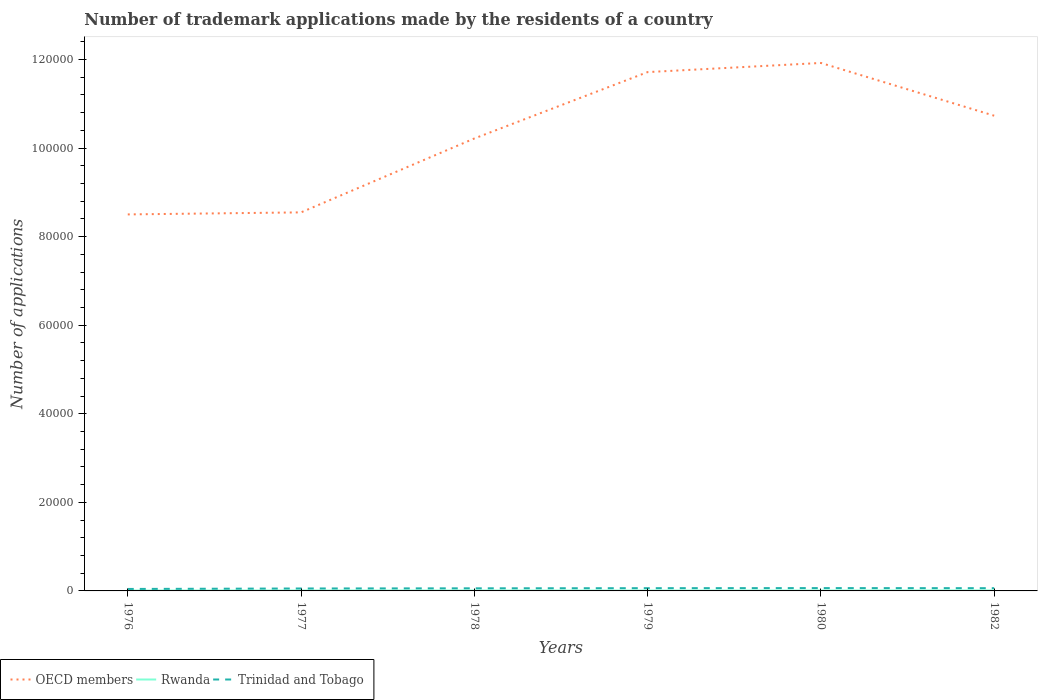How many different coloured lines are there?
Provide a short and direct response. 3. Across all years, what is the maximum number of trademark applications made by the residents in OECD members?
Provide a succinct answer. 8.50e+04. In which year was the number of trademark applications made by the residents in Rwanda maximum?
Offer a terse response. 1979. What is the difference between the highest and the second highest number of trademark applications made by the residents in OECD members?
Your answer should be compact. 3.42e+04. Is the number of trademark applications made by the residents in Rwanda strictly greater than the number of trademark applications made by the residents in OECD members over the years?
Keep it short and to the point. Yes. How many years are there in the graph?
Keep it short and to the point. 6. Are the values on the major ticks of Y-axis written in scientific E-notation?
Offer a terse response. No. Does the graph contain grids?
Ensure brevity in your answer.  No. How are the legend labels stacked?
Make the answer very short. Horizontal. What is the title of the graph?
Ensure brevity in your answer.  Number of trademark applications made by the residents of a country. Does "Azerbaijan" appear as one of the legend labels in the graph?
Your response must be concise. No. What is the label or title of the X-axis?
Make the answer very short. Years. What is the label or title of the Y-axis?
Offer a very short reply. Number of applications. What is the Number of applications in OECD members in 1976?
Keep it short and to the point. 8.50e+04. What is the Number of applications of Trinidad and Tobago in 1976?
Offer a very short reply. 443. What is the Number of applications of OECD members in 1977?
Keep it short and to the point. 8.55e+04. What is the Number of applications of Rwanda in 1977?
Your answer should be very brief. 90. What is the Number of applications in Trinidad and Tobago in 1977?
Offer a very short reply. 550. What is the Number of applications of OECD members in 1978?
Offer a terse response. 1.02e+05. What is the Number of applications of Trinidad and Tobago in 1978?
Offer a very short reply. 589. What is the Number of applications of OECD members in 1979?
Your response must be concise. 1.17e+05. What is the Number of applications of Trinidad and Tobago in 1979?
Keep it short and to the point. 621. What is the Number of applications of OECD members in 1980?
Give a very brief answer. 1.19e+05. What is the Number of applications in Trinidad and Tobago in 1980?
Your answer should be compact. 640. What is the Number of applications in OECD members in 1982?
Offer a very short reply. 1.07e+05. What is the Number of applications of Rwanda in 1982?
Offer a terse response. 106. What is the Number of applications in Trinidad and Tobago in 1982?
Keep it short and to the point. 621. Across all years, what is the maximum Number of applications of OECD members?
Provide a succinct answer. 1.19e+05. Across all years, what is the maximum Number of applications in Rwanda?
Make the answer very short. 106. Across all years, what is the maximum Number of applications of Trinidad and Tobago?
Your answer should be compact. 640. Across all years, what is the minimum Number of applications in OECD members?
Offer a terse response. 8.50e+04. Across all years, what is the minimum Number of applications of Trinidad and Tobago?
Keep it short and to the point. 443. What is the total Number of applications of OECD members in the graph?
Ensure brevity in your answer.  6.16e+05. What is the total Number of applications in Rwanda in the graph?
Your answer should be compact. 537. What is the total Number of applications of Trinidad and Tobago in the graph?
Offer a very short reply. 3464. What is the difference between the Number of applications in OECD members in 1976 and that in 1977?
Your answer should be compact. -459. What is the difference between the Number of applications in Trinidad and Tobago in 1976 and that in 1977?
Offer a terse response. -107. What is the difference between the Number of applications of OECD members in 1976 and that in 1978?
Offer a terse response. -1.71e+04. What is the difference between the Number of applications in Trinidad and Tobago in 1976 and that in 1978?
Your answer should be compact. -146. What is the difference between the Number of applications of OECD members in 1976 and that in 1979?
Offer a terse response. -3.21e+04. What is the difference between the Number of applications in Trinidad and Tobago in 1976 and that in 1979?
Ensure brevity in your answer.  -178. What is the difference between the Number of applications in OECD members in 1976 and that in 1980?
Your answer should be very brief. -3.42e+04. What is the difference between the Number of applications of Trinidad and Tobago in 1976 and that in 1980?
Give a very brief answer. -197. What is the difference between the Number of applications in OECD members in 1976 and that in 1982?
Make the answer very short. -2.23e+04. What is the difference between the Number of applications of Rwanda in 1976 and that in 1982?
Give a very brief answer. -23. What is the difference between the Number of applications of Trinidad and Tobago in 1976 and that in 1982?
Give a very brief answer. -178. What is the difference between the Number of applications of OECD members in 1977 and that in 1978?
Your response must be concise. -1.67e+04. What is the difference between the Number of applications of Trinidad and Tobago in 1977 and that in 1978?
Offer a very short reply. -39. What is the difference between the Number of applications in OECD members in 1977 and that in 1979?
Your answer should be very brief. -3.17e+04. What is the difference between the Number of applications in Trinidad and Tobago in 1977 and that in 1979?
Make the answer very short. -71. What is the difference between the Number of applications in OECD members in 1977 and that in 1980?
Provide a succinct answer. -3.37e+04. What is the difference between the Number of applications in Trinidad and Tobago in 1977 and that in 1980?
Make the answer very short. -90. What is the difference between the Number of applications in OECD members in 1977 and that in 1982?
Give a very brief answer. -2.18e+04. What is the difference between the Number of applications of Trinidad and Tobago in 1977 and that in 1982?
Keep it short and to the point. -71. What is the difference between the Number of applications of OECD members in 1978 and that in 1979?
Provide a short and direct response. -1.50e+04. What is the difference between the Number of applications in Trinidad and Tobago in 1978 and that in 1979?
Ensure brevity in your answer.  -32. What is the difference between the Number of applications in OECD members in 1978 and that in 1980?
Your answer should be compact. -1.71e+04. What is the difference between the Number of applications of Rwanda in 1978 and that in 1980?
Offer a very short reply. 3. What is the difference between the Number of applications in Trinidad and Tobago in 1978 and that in 1980?
Ensure brevity in your answer.  -51. What is the difference between the Number of applications in OECD members in 1978 and that in 1982?
Provide a succinct answer. -5143. What is the difference between the Number of applications of Rwanda in 1978 and that in 1982?
Offer a terse response. -16. What is the difference between the Number of applications of Trinidad and Tobago in 1978 and that in 1982?
Your answer should be very brief. -32. What is the difference between the Number of applications in OECD members in 1979 and that in 1980?
Provide a succinct answer. -2065. What is the difference between the Number of applications in OECD members in 1979 and that in 1982?
Ensure brevity in your answer.  9848. What is the difference between the Number of applications in Rwanda in 1979 and that in 1982?
Your response must be concise. -25. What is the difference between the Number of applications in Trinidad and Tobago in 1979 and that in 1982?
Offer a very short reply. 0. What is the difference between the Number of applications of OECD members in 1980 and that in 1982?
Your answer should be compact. 1.19e+04. What is the difference between the Number of applications in Rwanda in 1980 and that in 1982?
Your answer should be very brief. -19. What is the difference between the Number of applications in OECD members in 1976 and the Number of applications in Rwanda in 1977?
Keep it short and to the point. 8.49e+04. What is the difference between the Number of applications of OECD members in 1976 and the Number of applications of Trinidad and Tobago in 1977?
Make the answer very short. 8.45e+04. What is the difference between the Number of applications of Rwanda in 1976 and the Number of applications of Trinidad and Tobago in 1977?
Make the answer very short. -467. What is the difference between the Number of applications of OECD members in 1976 and the Number of applications of Rwanda in 1978?
Keep it short and to the point. 8.49e+04. What is the difference between the Number of applications in OECD members in 1976 and the Number of applications in Trinidad and Tobago in 1978?
Your answer should be compact. 8.44e+04. What is the difference between the Number of applications in Rwanda in 1976 and the Number of applications in Trinidad and Tobago in 1978?
Offer a very short reply. -506. What is the difference between the Number of applications of OECD members in 1976 and the Number of applications of Rwanda in 1979?
Offer a very short reply. 8.50e+04. What is the difference between the Number of applications in OECD members in 1976 and the Number of applications in Trinidad and Tobago in 1979?
Give a very brief answer. 8.44e+04. What is the difference between the Number of applications in Rwanda in 1976 and the Number of applications in Trinidad and Tobago in 1979?
Make the answer very short. -538. What is the difference between the Number of applications in OECD members in 1976 and the Number of applications in Rwanda in 1980?
Make the answer very short. 8.49e+04. What is the difference between the Number of applications of OECD members in 1976 and the Number of applications of Trinidad and Tobago in 1980?
Offer a very short reply. 8.44e+04. What is the difference between the Number of applications in Rwanda in 1976 and the Number of applications in Trinidad and Tobago in 1980?
Provide a succinct answer. -557. What is the difference between the Number of applications in OECD members in 1976 and the Number of applications in Rwanda in 1982?
Your answer should be very brief. 8.49e+04. What is the difference between the Number of applications in OECD members in 1976 and the Number of applications in Trinidad and Tobago in 1982?
Ensure brevity in your answer.  8.44e+04. What is the difference between the Number of applications in Rwanda in 1976 and the Number of applications in Trinidad and Tobago in 1982?
Your answer should be compact. -538. What is the difference between the Number of applications of OECD members in 1977 and the Number of applications of Rwanda in 1978?
Your answer should be very brief. 8.54e+04. What is the difference between the Number of applications in OECD members in 1977 and the Number of applications in Trinidad and Tobago in 1978?
Make the answer very short. 8.49e+04. What is the difference between the Number of applications of Rwanda in 1977 and the Number of applications of Trinidad and Tobago in 1978?
Make the answer very short. -499. What is the difference between the Number of applications of OECD members in 1977 and the Number of applications of Rwanda in 1979?
Offer a very short reply. 8.54e+04. What is the difference between the Number of applications in OECD members in 1977 and the Number of applications in Trinidad and Tobago in 1979?
Provide a short and direct response. 8.49e+04. What is the difference between the Number of applications in Rwanda in 1977 and the Number of applications in Trinidad and Tobago in 1979?
Offer a very short reply. -531. What is the difference between the Number of applications of OECD members in 1977 and the Number of applications of Rwanda in 1980?
Provide a short and direct response. 8.54e+04. What is the difference between the Number of applications in OECD members in 1977 and the Number of applications in Trinidad and Tobago in 1980?
Your response must be concise. 8.48e+04. What is the difference between the Number of applications in Rwanda in 1977 and the Number of applications in Trinidad and Tobago in 1980?
Give a very brief answer. -550. What is the difference between the Number of applications of OECD members in 1977 and the Number of applications of Rwanda in 1982?
Provide a succinct answer. 8.54e+04. What is the difference between the Number of applications of OECD members in 1977 and the Number of applications of Trinidad and Tobago in 1982?
Keep it short and to the point. 8.49e+04. What is the difference between the Number of applications in Rwanda in 1977 and the Number of applications in Trinidad and Tobago in 1982?
Ensure brevity in your answer.  -531. What is the difference between the Number of applications of OECD members in 1978 and the Number of applications of Rwanda in 1979?
Your response must be concise. 1.02e+05. What is the difference between the Number of applications of OECD members in 1978 and the Number of applications of Trinidad and Tobago in 1979?
Give a very brief answer. 1.02e+05. What is the difference between the Number of applications of Rwanda in 1978 and the Number of applications of Trinidad and Tobago in 1979?
Your answer should be very brief. -531. What is the difference between the Number of applications of OECD members in 1978 and the Number of applications of Rwanda in 1980?
Provide a short and direct response. 1.02e+05. What is the difference between the Number of applications in OECD members in 1978 and the Number of applications in Trinidad and Tobago in 1980?
Offer a very short reply. 1.02e+05. What is the difference between the Number of applications of Rwanda in 1978 and the Number of applications of Trinidad and Tobago in 1980?
Your answer should be very brief. -550. What is the difference between the Number of applications of OECD members in 1978 and the Number of applications of Rwanda in 1982?
Make the answer very short. 1.02e+05. What is the difference between the Number of applications in OECD members in 1978 and the Number of applications in Trinidad and Tobago in 1982?
Make the answer very short. 1.02e+05. What is the difference between the Number of applications in Rwanda in 1978 and the Number of applications in Trinidad and Tobago in 1982?
Your response must be concise. -531. What is the difference between the Number of applications in OECD members in 1979 and the Number of applications in Rwanda in 1980?
Give a very brief answer. 1.17e+05. What is the difference between the Number of applications in OECD members in 1979 and the Number of applications in Trinidad and Tobago in 1980?
Keep it short and to the point. 1.17e+05. What is the difference between the Number of applications of Rwanda in 1979 and the Number of applications of Trinidad and Tobago in 1980?
Ensure brevity in your answer.  -559. What is the difference between the Number of applications in OECD members in 1979 and the Number of applications in Rwanda in 1982?
Provide a succinct answer. 1.17e+05. What is the difference between the Number of applications of OECD members in 1979 and the Number of applications of Trinidad and Tobago in 1982?
Make the answer very short. 1.17e+05. What is the difference between the Number of applications in Rwanda in 1979 and the Number of applications in Trinidad and Tobago in 1982?
Make the answer very short. -540. What is the difference between the Number of applications in OECD members in 1980 and the Number of applications in Rwanda in 1982?
Ensure brevity in your answer.  1.19e+05. What is the difference between the Number of applications in OECD members in 1980 and the Number of applications in Trinidad and Tobago in 1982?
Give a very brief answer. 1.19e+05. What is the difference between the Number of applications of Rwanda in 1980 and the Number of applications of Trinidad and Tobago in 1982?
Make the answer very short. -534. What is the average Number of applications of OECD members per year?
Keep it short and to the point. 1.03e+05. What is the average Number of applications of Rwanda per year?
Ensure brevity in your answer.  89.5. What is the average Number of applications in Trinidad and Tobago per year?
Give a very brief answer. 577.33. In the year 1976, what is the difference between the Number of applications of OECD members and Number of applications of Rwanda?
Your answer should be very brief. 8.49e+04. In the year 1976, what is the difference between the Number of applications in OECD members and Number of applications in Trinidad and Tobago?
Keep it short and to the point. 8.46e+04. In the year 1976, what is the difference between the Number of applications in Rwanda and Number of applications in Trinidad and Tobago?
Your response must be concise. -360. In the year 1977, what is the difference between the Number of applications in OECD members and Number of applications in Rwanda?
Give a very brief answer. 8.54e+04. In the year 1977, what is the difference between the Number of applications of OECD members and Number of applications of Trinidad and Tobago?
Your answer should be compact. 8.49e+04. In the year 1977, what is the difference between the Number of applications of Rwanda and Number of applications of Trinidad and Tobago?
Make the answer very short. -460. In the year 1978, what is the difference between the Number of applications in OECD members and Number of applications in Rwanda?
Your answer should be compact. 1.02e+05. In the year 1978, what is the difference between the Number of applications of OECD members and Number of applications of Trinidad and Tobago?
Offer a very short reply. 1.02e+05. In the year 1978, what is the difference between the Number of applications of Rwanda and Number of applications of Trinidad and Tobago?
Make the answer very short. -499. In the year 1979, what is the difference between the Number of applications of OECD members and Number of applications of Rwanda?
Ensure brevity in your answer.  1.17e+05. In the year 1979, what is the difference between the Number of applications of OECD members and Number of applications of Trinidad and Tobago?
Your answer should be very brief. 1.17e+05. In the year 1979, what is the difference between the Number of applications in Rwanda and Number of applications in Trinidad and Tobago?
Your answer should be compact. -540. In the year 1980, what is the difference between the Number of applications in OECD members and Number of applications in Rwanda?
Provide a succinct answer. 1.19e+05. In the year 1980, what is the difference between the Number of applications in OECD members and Number of applications in Trinidad and Tobago?
Keep it short and to the point. 1.19e+05. In the year 1980, what is the difference between the Number of applications in Rwanda and Number of applications in Trinidad and Tobago?
Keep it short and to the point. -553. In the year 1982, what is the difference between the Number of applications of OECD members and Number of applications of Rwanda?
Offer a very short reply. 1.07e+05. In the year 1982, what is the difference between the Number of applications of OECD members and Number of applications of Trinidad and Tobago?
Provide a short and direct response. 1.07e+05. In the year 1982, what is the difference between the Number of applications of Rwanda and Number of applications of Trinidad and Tobago?
Offer a terse response. -515. What is the ratio of the Number of applications in Rwanda in 1976 to that in 1977?
Your answer should be very brief. 0.92. What is the ratio of the Number of applications of Trinidad and Tobago in 1976 to that in 1977?
Your response must be concise. 0.81. What is the ratio of the Number of applications in OECD members in 1976 to that in 1978?
Offer a very short reply. 0.83. What is the ratio of the Number of applications in Rwanda in 1976 to that in 1978?
Provide a short and direct response. 0.92. What is the ratio of the Number of applications in Trinidad and Tobago in 1976 to that in 1978?
Offer a very short reply. 0.75. What is the ratio of the Number of applications in OECD members in 1976 to that in 1979?
Provide a succinct answer. 0.73. What is the ratio of the Number of applications of Rwanda in 1976 to that in 1979?
Make the answer very short. 1.02. What is the ratio of the Number of applications of Trinidad and Tobago in 1976 to that in 1979?
Make the answer very short. 0.71. What is the ratio of the Number of applications in OECD members in 1976 to that in 1980?
Offer a very short reply. 0.71. What is the ratio of the Number of applications of Rwanda in 1976 to that in 1980?
Offer a terse response. 0.95. What is the ratio of the Number of applications of Trinidad and Tobago in 1976 to that in 1980?
Provide a succinct answer. 0.69. What is the ratio of the Number of applications in OECD members in 1976 to that in 1982?
Your answer should be very brief. 0.79. What is the ratio of the Number of applications of Rwanda in 1976 to that in 1982?
Make the answer very short. 0.78. What is the ratio of the Number of applications of Trinidad and Tobago in 1976 to that in 1982?
Give a very brief answer. 0.71. What is the ratio of the Number of applications in OECD members in 1977 to that in 1978?
Your response must be concise. 0.84. What is the ratio of the Number of applications in Rwanda in 1977 to that in 1978?
Your answer should be compact. 1. What is the ratio of the Number of applications of Trinidad and Tobago in 1977 to that in 1978?
Provide a short and direct response. 0.93. What is the ratio of the Number of applications of OECD members in 1977 to that in 1979?
Your answer should be compact. 0.73. What is the ratio of the Number of applications in Rwanda in 1977 to that in 1979?
Your answer should be very brief. 1.11. What is the ratio of the Number of applications of Trinidad and Tobago in 1977 to that in 1979?
Make the answer very short. 0.89. What is the ratio of the Number of applications in OECD members in 1977 to that in 1980?
Keep it short and to the point. 0.72. What is the ratio of the Number of applications of Rwanda in 1977 to that in 1980?
Ensure brevity in your answer.  1.03. What is the ratio of the Number of applications of Trinidad and Tobago in 1977 to that in 1980?
Keep it short and to the point. 0.86. What is the ratio of the Number of applications in OECD members in 1977 to that in 1982?
Your answer should be very brief. 0.8. What is the ratio of the Number of applications in Rwanda in 1977 to that in 1982?
Provide a succinct answer. 0.85. What is the ratio of the Number of applications of Trinidad and Tobago in 1977 to that in 1982?
Give a very brief answer. 0.89. What is the ratio of the Number of applications of OECD members in 1978 to that in 1979?
Give a very brief answer. 0.87. What is the ratio of the Number of applications of Rwanda in 1978 to that in 1979?
Ensure brevity in your answer.  1.11. What is the ratio of the Number of applications in Trinidad and Tobago in 1978 to that in 1979?
Ensure brevity in your answer.  0.95. What is the ratio of the Number of applications in OECD members in 1978 to that in 1980?
Provide a short and direct response. 0.86. What is the ratio of the Number of applications of Rwanda in 1978 to that in 1980?
Your answer should be compact. 1.03. What is the ratio of the Number of applications of Trinidad and Tobago in 1978 to that in 1980?
Offer a very short reply. 0.92. What is the ratio of the Number of applications of OECD members in 1978 to that in 1982?
Your answer should be compact. 0.95. What is the ratio of the Number of applications in Rwanda in 1978 to that in 1982?
Keep it short and to the point. 0.85. What is the ratio of the Number of applications of Trinidad and Tobago in 1978 to that in 1982?
Offer a terse response. 0.95. What is the ratio of the Number of applications in OECD members in 1979 to that in 1980?
Your answer should be compact. 0.98. What is the ratio of the Number of applications in Trinidad and Tobago in 1979 to that in 1980?
Keep it short and to the point. 0.97. What is the ratio of the Number of applications of OECD members in 1979 to that in 1982?
Offer a very short reply. 1.09. What is the ratio of the Number of applications of Rwanda in 1979 to that in 1982?
Keep it short and to the point. 0.76. What is the ratio of the Number of applications of OECD members in 1980 to that in 1982?
Your answer should be very brief. 1.11. What is the ratio of the Number of applications in Rwanda in 1980 to that in 1982?
Ensure brevity in your answer.  0.82. What is the ratio of the Number of applications in Trinidad and Tobago in 1980 to that in 1982?
Your response must be concise. 1.03. What is the difference between the highest and the second highest Number of applications in OECD members?
Your answer should be very brief. 2065. What is the difference between the highest and the second highest Number of applications in Rwanda?
Offer a very short reply. 16. What is the difference between the highest and the second highest Number of applications of Trinidad and Tobago?
Provide a succinct answer. 19. What is the difference between the highest and the lowest Number of applications of OECD members?
Ensure brevity in your answer.  3.42e+04. What is the difference between the highest and the lowest Number of applications in Rwanda?
Your answer should be very brief. 25. What is the difference between the highest and the lowest Number of applications of Trinidad and Tobago?
Give a very brief answer. 197. 